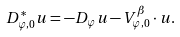<formula> <loc_0><loc_0><loc_500><loc_500>D ^ { * } _ { \varphi , 0 } u = - D _ { \varphi } u - V ^ { \beta } _ { \varphi , 0 } \cdot u .</formula> 